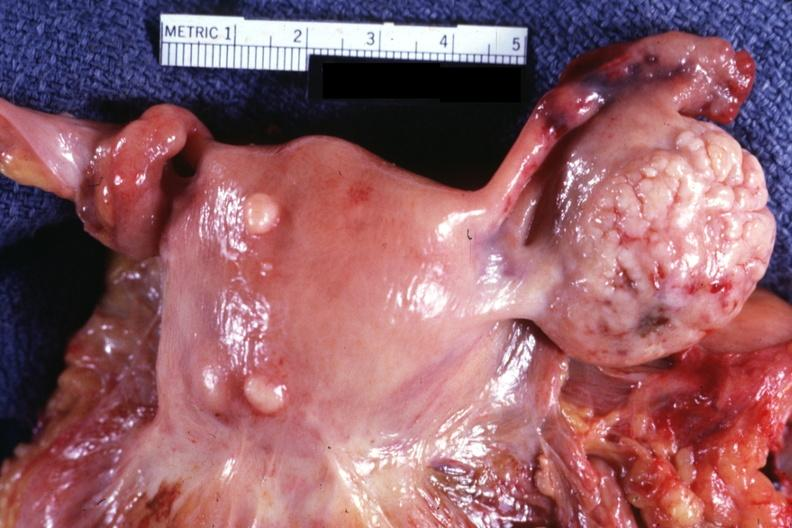s adrenal present?
Answer the question using a single word or phrase. No 